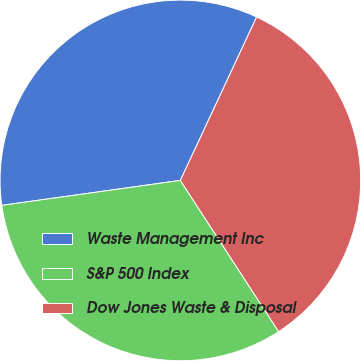Convert chart. <chart><loc_0><loc_0><loc_500><loc_500><pie_chart><fcel>Waste Management Inc<fcel>S&P 500 Index<fcel>Dow Jones Waste & Disposal<nl><fcel>34.16%<fcel>31.96%<fcel>33.88%<nl></chart> 